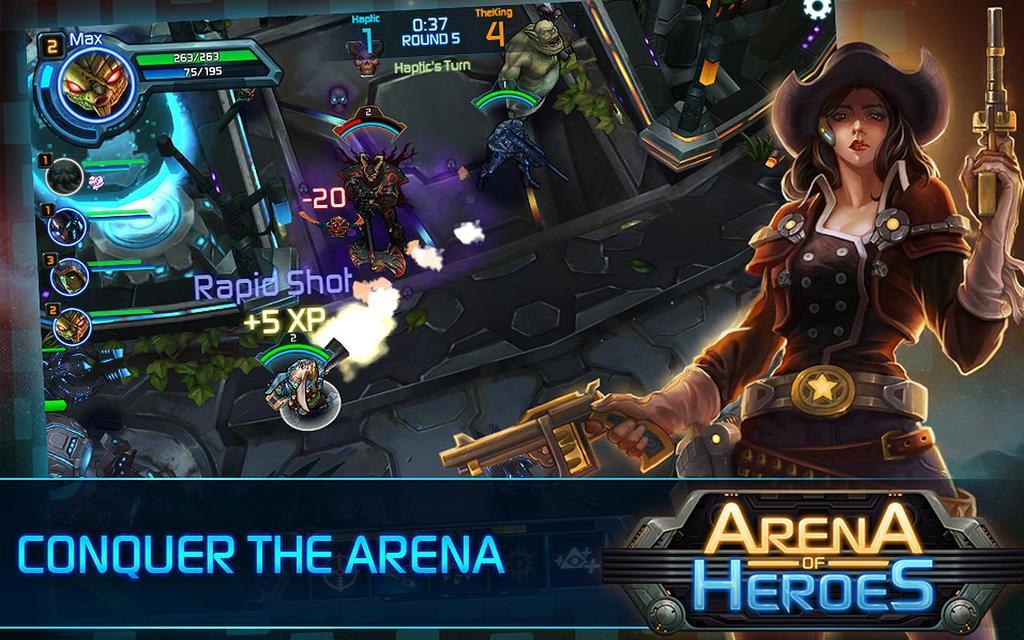What is the main subject of the image? There is an animation of a lady in the image. What else can be seen in the image besides the lady? There are objects, text, and logos in the image. How many horses are present in the image? There are no horses present in the image. What type of request can be seen in the text of the image? There is no request present in the image, as the text is not related to making a request. 